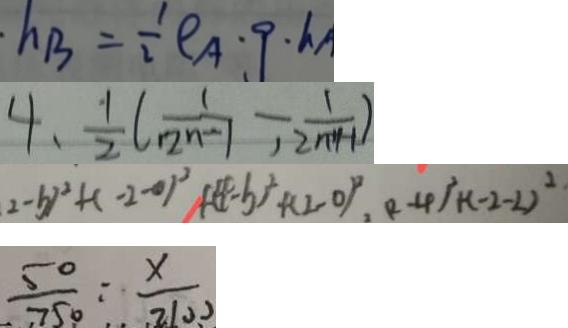<formula> <loc_0><loc_0><loc_500><loc_500>h _ { B } = \frac { 1 } { 2 } \rho A \cdot 9 \cdot h _ { A } 
 4 , \frac { 1 } { 2 } ( \frac { 1 } { 1 2 n - 1 } - \frac { 1 } { 1 2 n + 1 - 1 } ) 
 ( 2 - b ) ^ { 2 } + ( - 2 - 0 ) ^ { 2 } + ( 4 - b ) ^ { 2 } + ( 2 - 0 ) ^ { 2 } , ( 2 - 4 ) ^ { 2 } + ( - 2 - 2 ) ^ { 2 } 
 \frac { 5 0 } { 7 5 0 } : \frac { x } { 2 1 0 0 }</formula> 